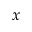Convert formula to latex. <formula><loc_0><loc_0><loc_500><loc_500>x</formula> 